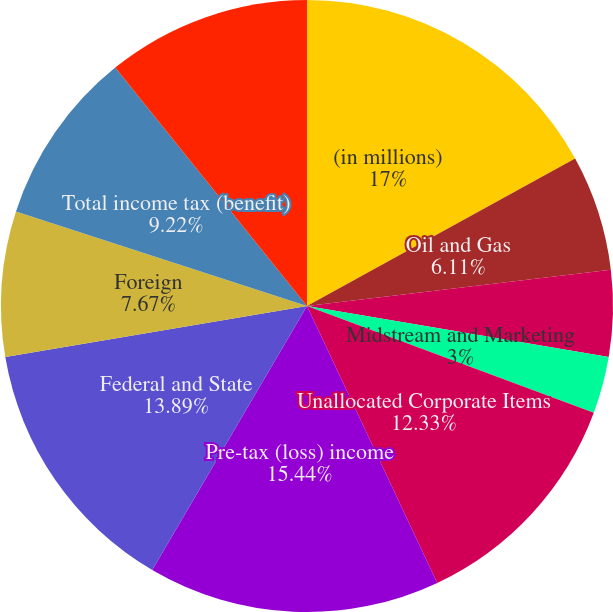Convert chart to OTSL. <chart><loc_0><loc_0><loc_500><loc_500><pie_chart><fcel>(in millions)<fcel>Oil and Gas<fcel>Chemical<fcel>Midstream and Marketing<fcel>Unallocated Corporate Items<fcel>Pre-tax (loss) income<fcel>Federal and State<fcel>Foreign<fcel>Total income tax (benefit)<fcel>Income (loss) from continuing<nl><fcel>17.0%<fcel>6.11%<fcel>4.56%<fcel>3.0%<fcel>12.33%<fcel>15.44%<fcel>13.89%<fcel>7.67%<fcel>9.22%<fcel>10.78%<nl></chart> 